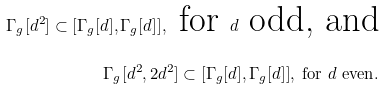Convert formula to latex. <formula><loc_0><loc_0><loc_500><loc_500>\Gamma _ { g } [ d ^ { 2 } ] \subset [ \Gamma _ { g } [ d ] , \Gamma _ { g } [ d ] ] , \text { for } d \text { odd, and} \\ \Gamma _ { g } [ d ^ { 2 } , 2 d ^ { 2 } ] \subset [ \Gamma _ { g } [ d ] , \Gamma _ { g } [ d ] ] , \text { for } d \text { even} .</formula> 